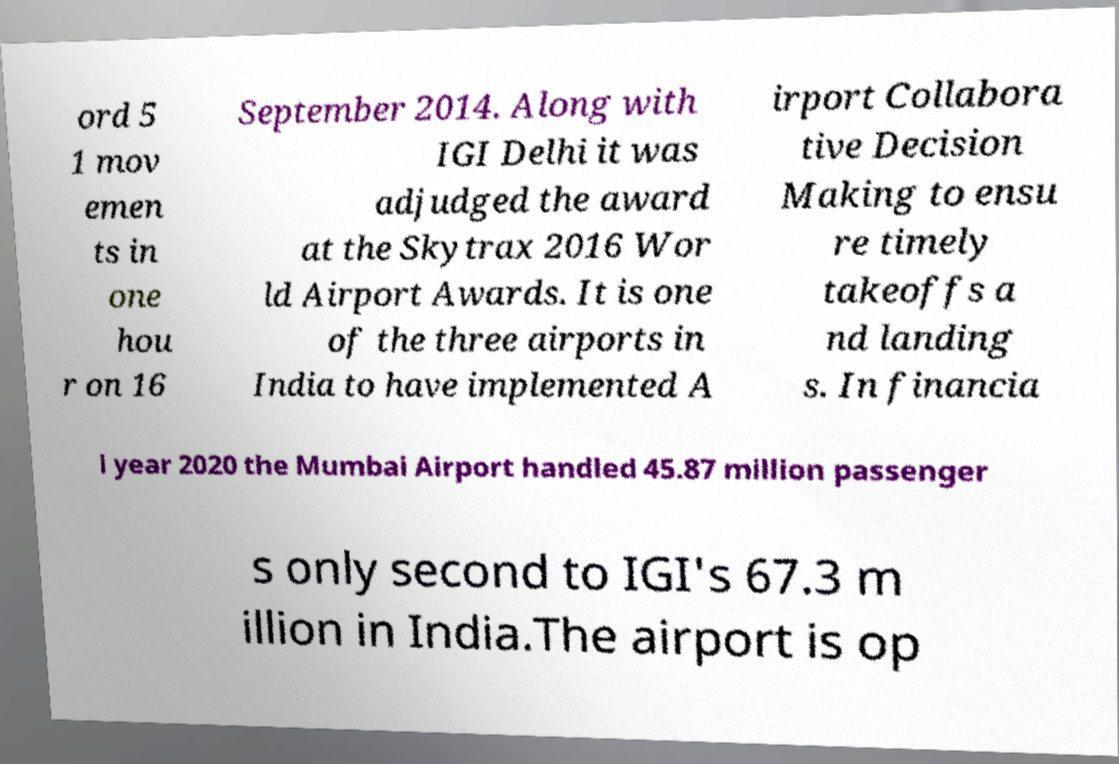Could you assist in decoding the text presented in this image and type it out clearly? ord 5 1 mov emen ts in one hou r on 16 September 2014. Along with IGI Delhi it was adjudged the award at the Skytrax 2016 Wor ld Airport Awards. It is one of the three airports in India to have implemented A irport Collabora tive Decision Making to ensu re timely takeoffs a nd landing s. In financia l year 2020 the Mumbai Airport handled 45.87 million passenger s only second to IGI's 67.3 m illion in India.The airport is op 